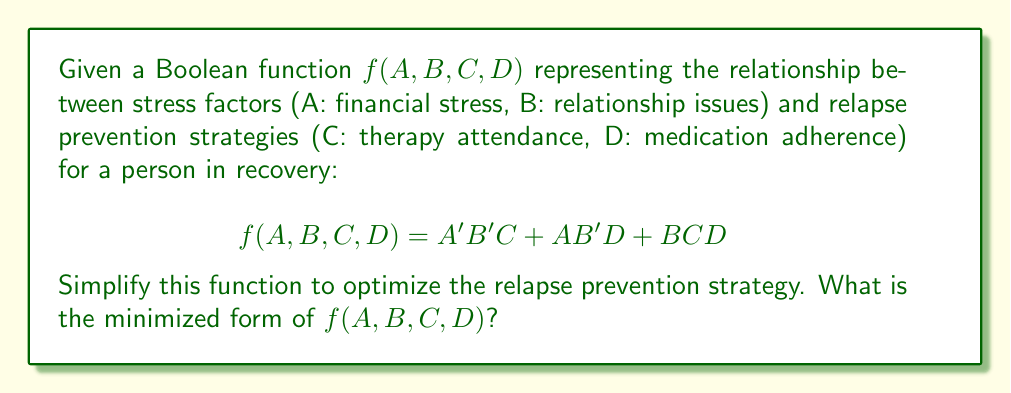Solve this math problem. Let's simplify the function using Boolean algebra laws:

1) First, let's distribute the term BCD:
   $$f(A,B,C,D) = A'B'C + AB'D + BCD$$
   $$= A'B'C + AB'D + BCD + BCD$$ (adding BCD doesn't change the function)

2) Now we can factor out BC:
   $$= A'B'C + AB'D + BC(D+1)$$

3) Since D+1 = 1 in Boolean algebra:
   $$= A'B'C + AB'D + BC$$

4) Let's focus on the first and third terms:
   $$A'B'C + BC = C(A'B' + B)$$

5) Using the absorption law, A'B' + B = A' + B:
   $$= C(A' + B) + AB'D$$

6) Distribute C:
   $$= A'C + BC + AB'D$$

This is the minimized form of the function.
Answer: $f(A,B,C,D) = A'C + BC + AB'D$ 